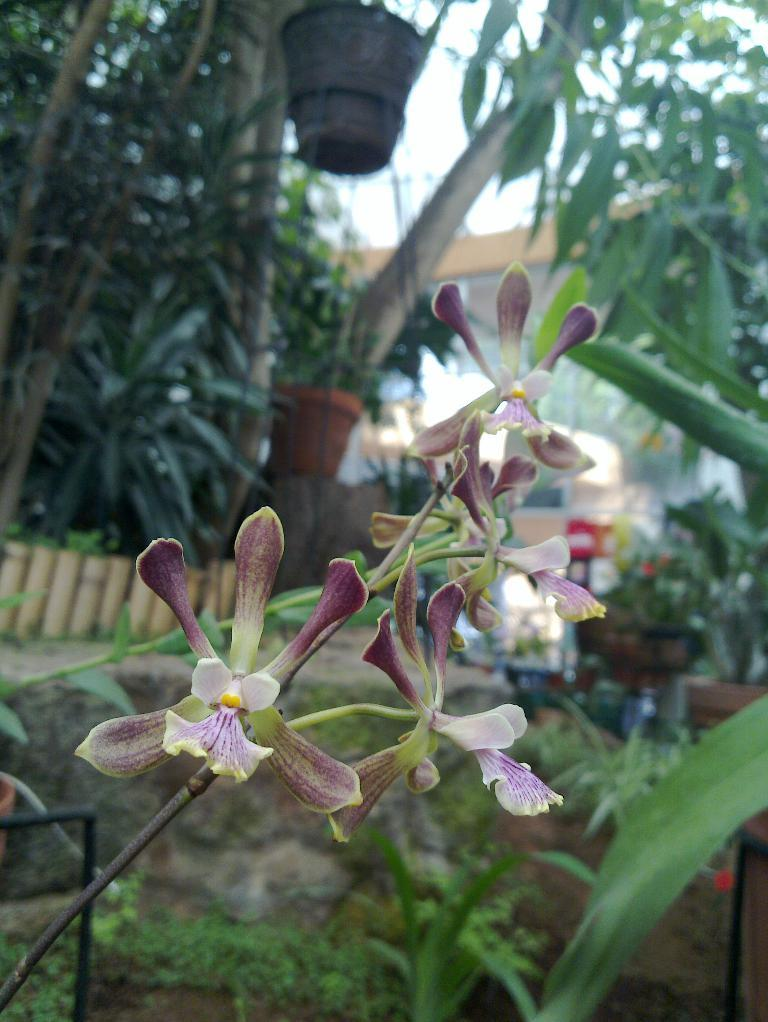What can be seen in the foreground of the picture? There are flowers and stems in the foreground of the picture. What is located at the bottom of the picture? There are plants at the bottom of the picture. What is visible in the background of the picture? There are trees, fencing, a building, a path, and other objects in the background of the picture. How many letters are visible on the neck of the person in the picture? There is no person present in the image, and therefore no neck or letters can be observed. What type of debt is being discussed in the picture? There is no discussion of debt in the picture; it features flowers, plants, trees, fencing, a building, a path, and other objects. 